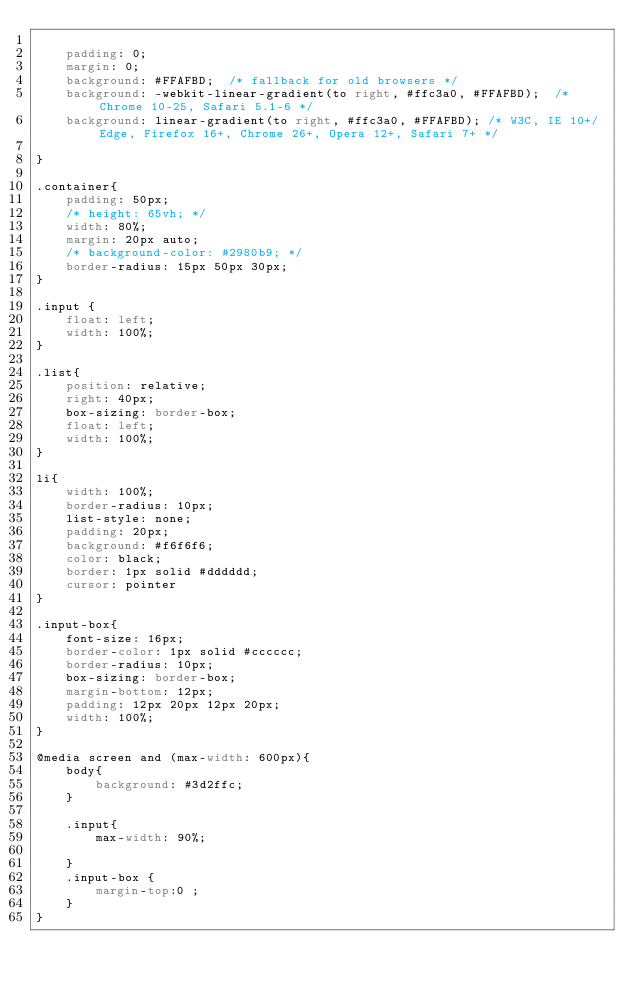Convert code to text. <code><loc_0><loc_0><loc_500><loc_500><_CSS_>    
    padding: 0;
    margin: 0;
    background: #FFAFBD;  /* fallback for old browsers */
    background: -webkit-linear-gradient(to right, #ffc3a0, #FFAFBD);  /* Chrome 10-25, Safari 5.1-6 */
    background: linear-gradient(to right, #ffc3a0, #FFAFBD); /* W3C, IE 10+/ Edge, Firefox 16+, Chrome 26+, Opera 12+, Safari 7+ */

}

.container{
    padding: 50px;
    /* height: 65vh; */
    width: 80%;
    margin: 20px auto;
    /* background-color: #2980b9; */
    border-radius: 15px 50px 30px;
}

.input {
    float: left;
    width: 100%;
}

.list{
    position: relative;
    right: 40px;
    box-sizing: border-box;
    float: left;
    width: 100%;
}

li{
    width: 100%;
    border-radius: 10px;
    list-style: none;
    padding: 20px;
    background: #f6f6f6;
    color: black;
    border: 1px solid #dddddd;
    cursor: pointer
}

.input-box{
    font-size: 16px;
    border-color: 1px solid #cccccc;
    border-radius: 10px;
    box-sizing: border-box;
    margin-bottom: 12px;
    padding: 12px 20px 12px 20px;
    width: 100%;
}

@media screen and (max-width: 600px){
    body{
        background: #3d2ffc;
    }
    
    .input{
        max-width: 90%;

    }
    .input-box {
        margin-top:0 ;
    }
}</code> 